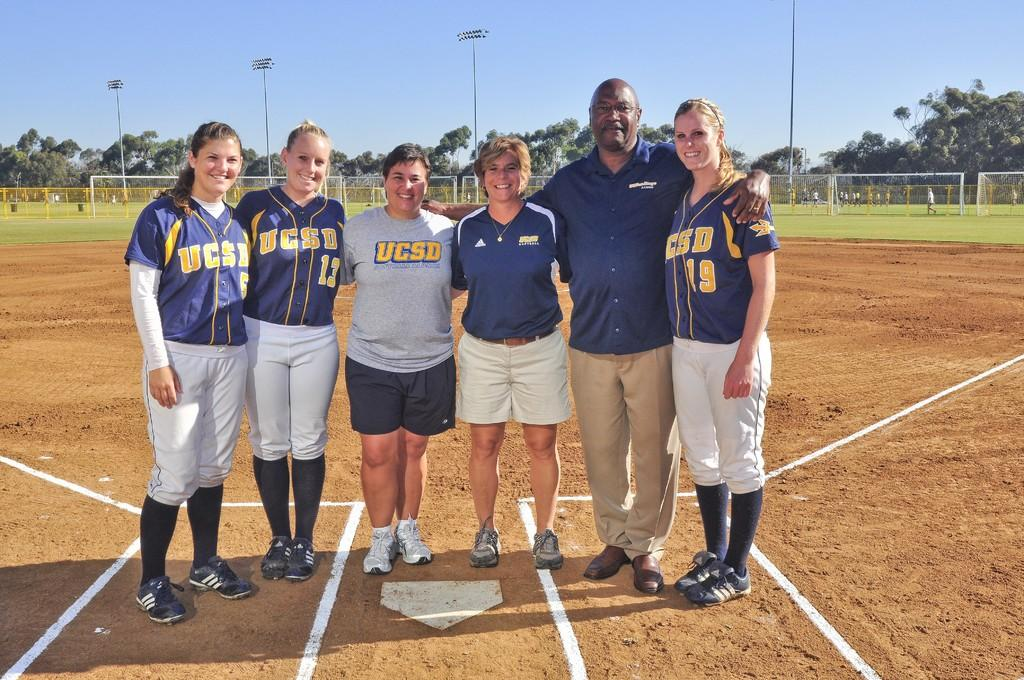<image>
Present a compact description of the photo's key features. a team that has the letters UCSD on them 